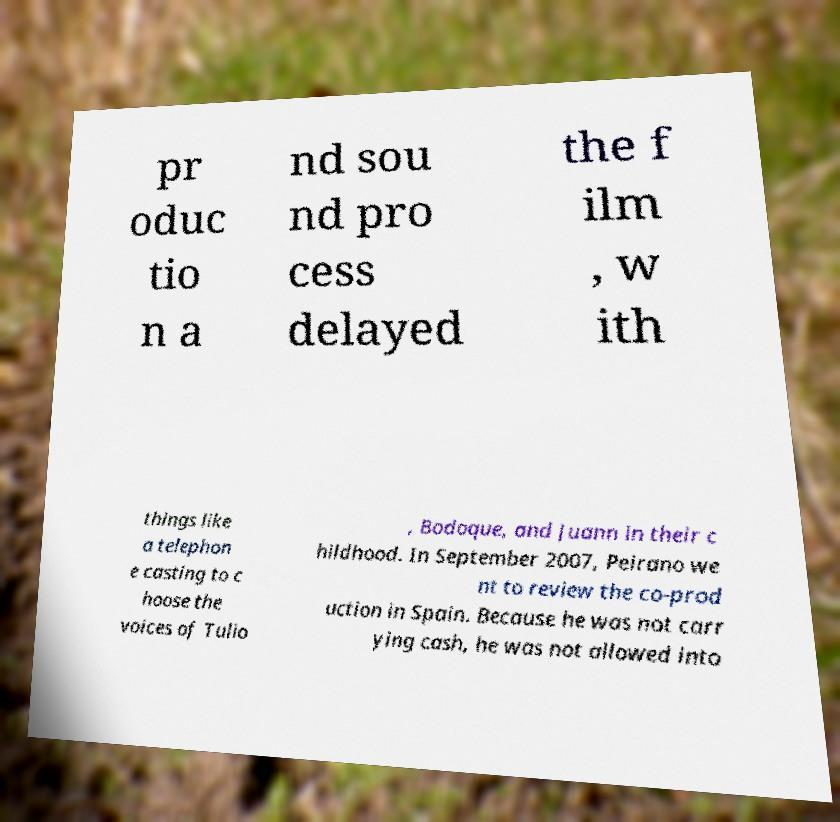Could you extract and type out the text from this image? pr oduc tio n a nd sou nd pro cess delayed the f ilm , w ith things like a telephon e casting to c hoose the voices of Tulio , Bodoque, and Juann in their c hildhood. In September 2007, Peirano we nt to review the co-prod uction in Spain. Because he was not carr ying cash, he was not allowed into 